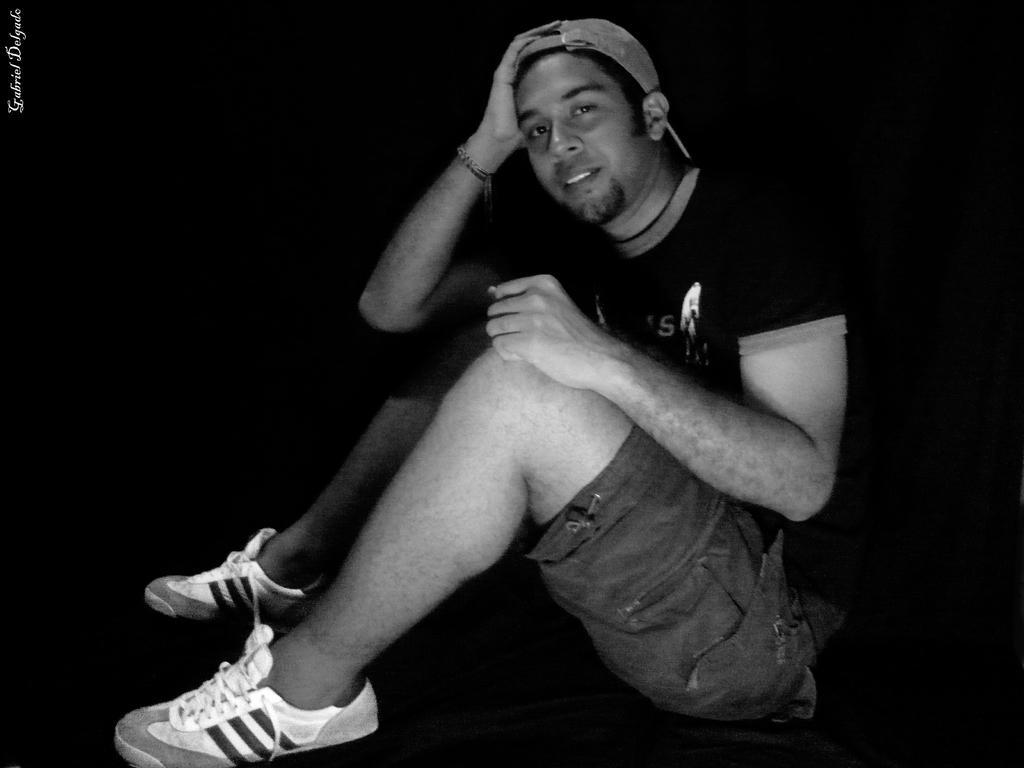Could you give a brief overview of what you see in this image? In the image there is a man sitting. And there is a cap on his head. In the top left corner of the image there is a name. 